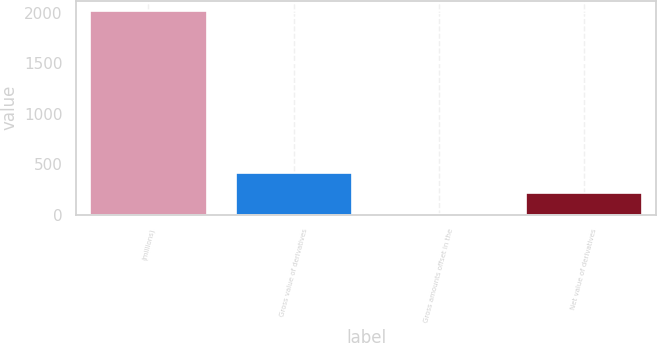<chart> <loc_0><loc_0><loc_500><loc_500><bar_chart><fcel>(millions)<fcel>Gross value of derivatives<fcel>Gross amounts offset in the<fcel>Net value of derivatives<nl><fcel>2015<fcel>410.84<fcel>9.8<fcel>210.32<nl></chart> 